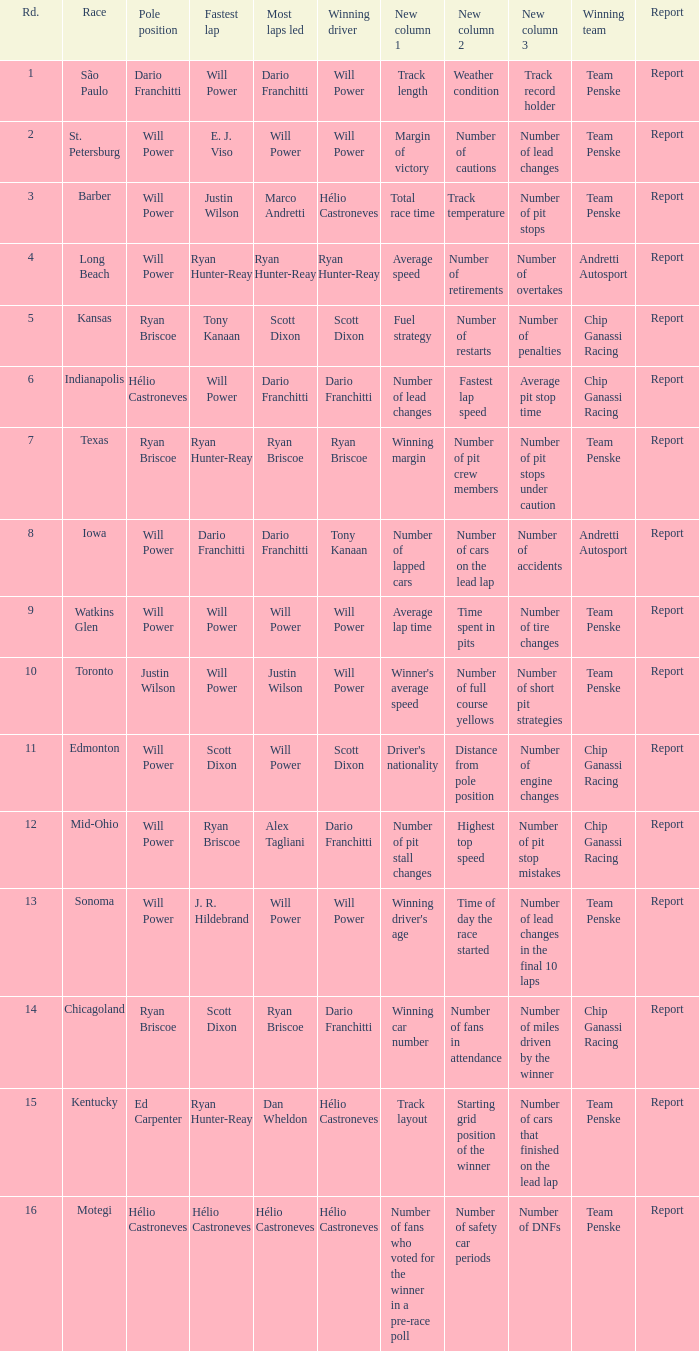Who was on the pole at Chicagoland? Ryan Briscoe. 